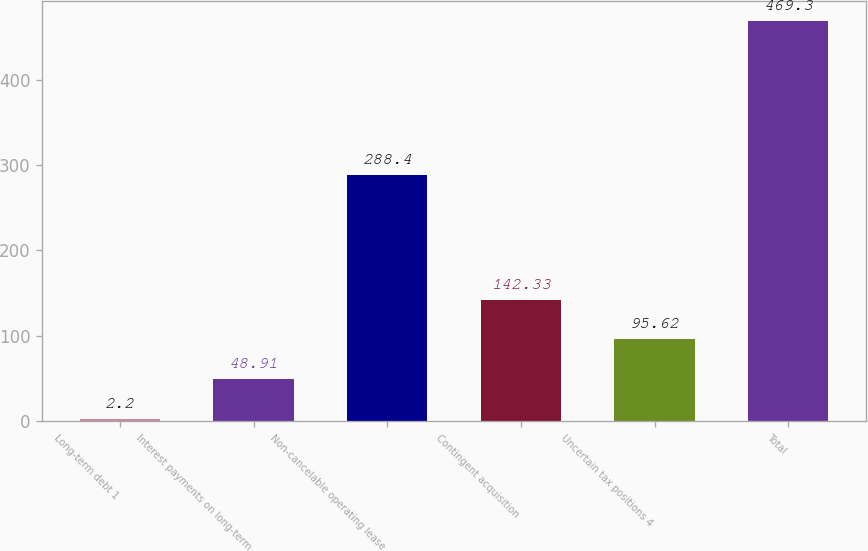Convert chart to OTSL. <chart><loc_0><loc_0><loc_500><loc_500><bar_chart><fcel>Long-term debt 1<fcel>Interest payments on long-term<fcel>Non-cancelable operating lease<fcel>Contingent acquisition<fcel>Uncertain tax positions 4<fcel>Total<nl><fcel>2.2<fcel>48.91<fcel>288.4<fcel>142.33<fcel>95.62<fcel>469.3<nl></chart> 